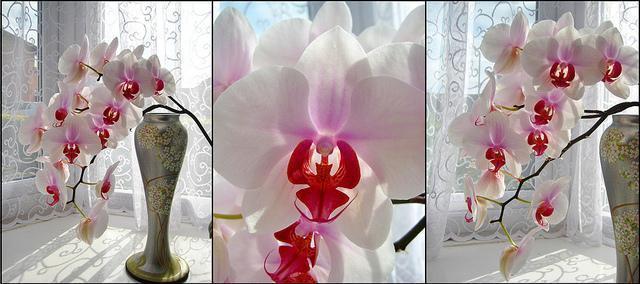How many pictures make up this photo?
Give a very brief answer. 3. How many vases are there?
Give a very brief answer. 2. 